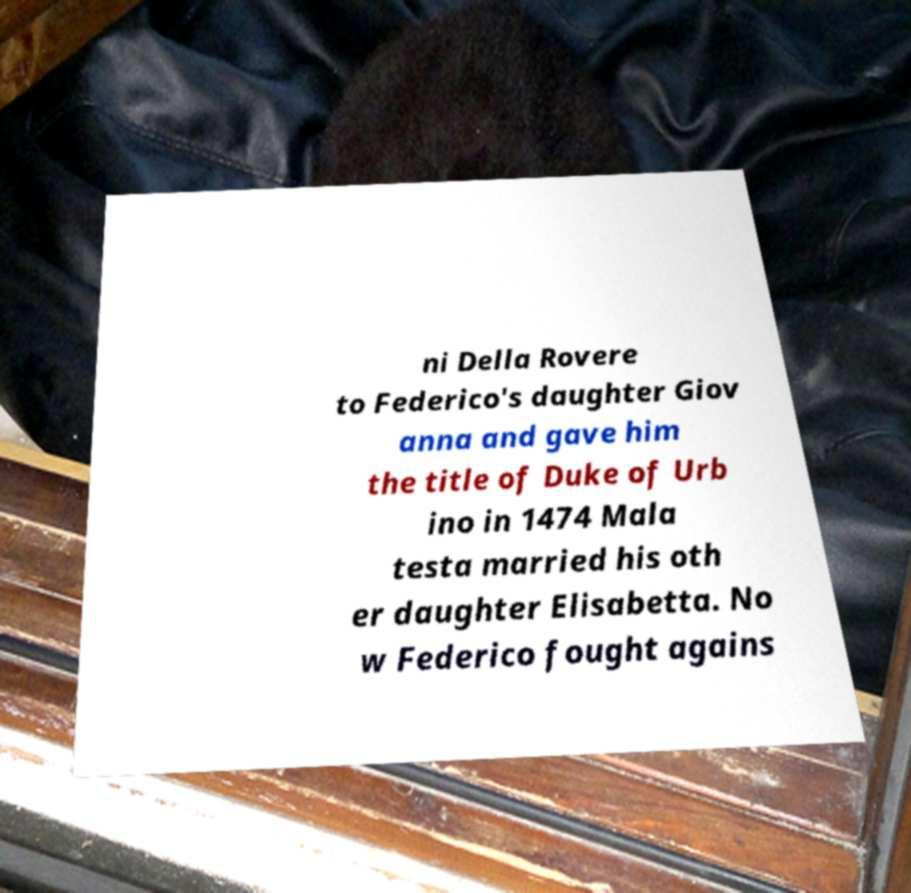Please read and relay the text visible in this image. What does it say? ni Della Rovere to Federico's daughter Giov anna and gave him the title of Duke of Urb ino in 1474 Mala testa married his oth er daughter Elisabetta. No w Federico fought agains 